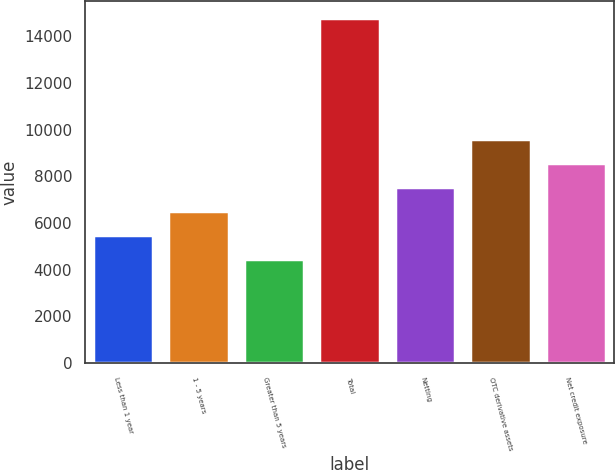<chart> <loc_0><loc_0><loc_500><loc_500><bar_chart><fcel>Less than 1 year<fcel>1 - 5 years<fcel>Greater than 5 years<fcel>Total<fcel>Netting<fcel>OTC derivative assets<fcel>Net credit exposure<nl><fcel>5472.9<fcel>6504.8<fcel>4441<fcel>14760<fcel>7536.7<fcel>9600.5<fcel>8568.6<nl></chart> 